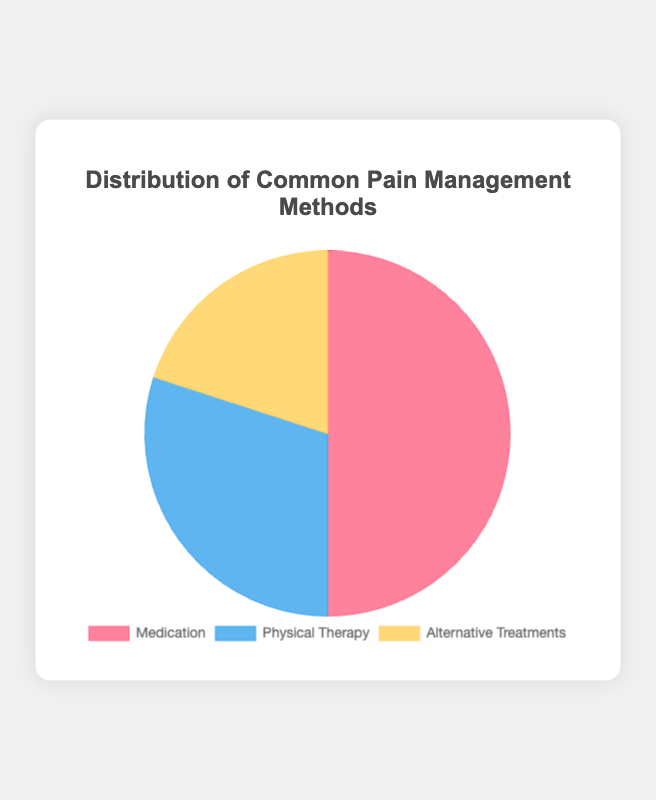What percentage of pain management methods involve Medication? First, identify the section labeled "Medication" in the pie chart. It shows 50% as its value.
Answer: 50% How does the proportion of Physical Therapy compare to Alternative Treatments? Compare the values of Physical Therapy (30%) and Alternative Treatments (20%). Physical Therapy has a higher percentage.
Answer: Physical Therapy has a higher percentage What is the combined percentage for Medication and Physical Therapy? Sum the percentages of Medication (50%) and Physical Therapy (30%). 50 + 30 = 80
Answer: 80% Which method of pain management occupies the smallest section of the pie chart, and what is its percentage? Identify the smallest section by visual inspection. The "Alternative Treatments" section, which is 20%, is the smallest.
Answer: Alternative Treatments, 20% Is there a balance between the three methods of pain management in the pie chart? Examine the three percentages: 50% for Medication, 30% for Physical Therapy, and 20% for Alternative Treatments. These values are not balanced as one section is notably larger.
Answer: No If you were to divide the pie chart into halves, would Medication alone cover more than half? Medication makes up 50%, which is exactly half of the chart.
Answer: No What is the difference in percentage between Medication and the combination of Physical Therapy and Alternative Treatments? Calculate the combined percentage of Physical Therapy and Alternative Treatments: 30% + 20% = 50%. Then find the difference with Medication: 50% - 50% = 0%
Answer: 0% If Alternative Treatments were doubled in percentage, what would its new value be and how would that affect the overall distribution? Doubling 20% gives 40%. The new distribution will show Medication at 50%, Physical Therapy at 30%, and Alternative Treatments at 40%.
Answer: 40%, Total exceeds 100% How much more percentage does Medication have compared to Physical Therapy? Subtract the percentage of Physical Therapy (30%) from Medication (50%). 50% - 30% = 20%
Answer: 20% List the pain management methods in descending order of their percentages. Arrange the percentages from highest to lowest: Medication (50%), Physical Therapy (30%), Alternative Treatments (20%)
Answer: Medication, Physical Therapy, Alternative Treatments 